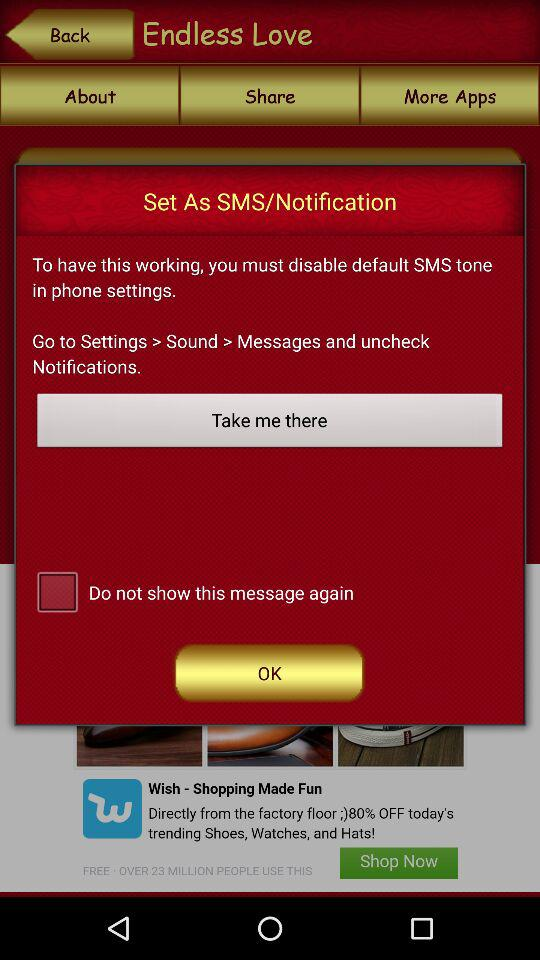What is the status of "Do not show this message again"? The status of "Do not show this message again" is "off". 